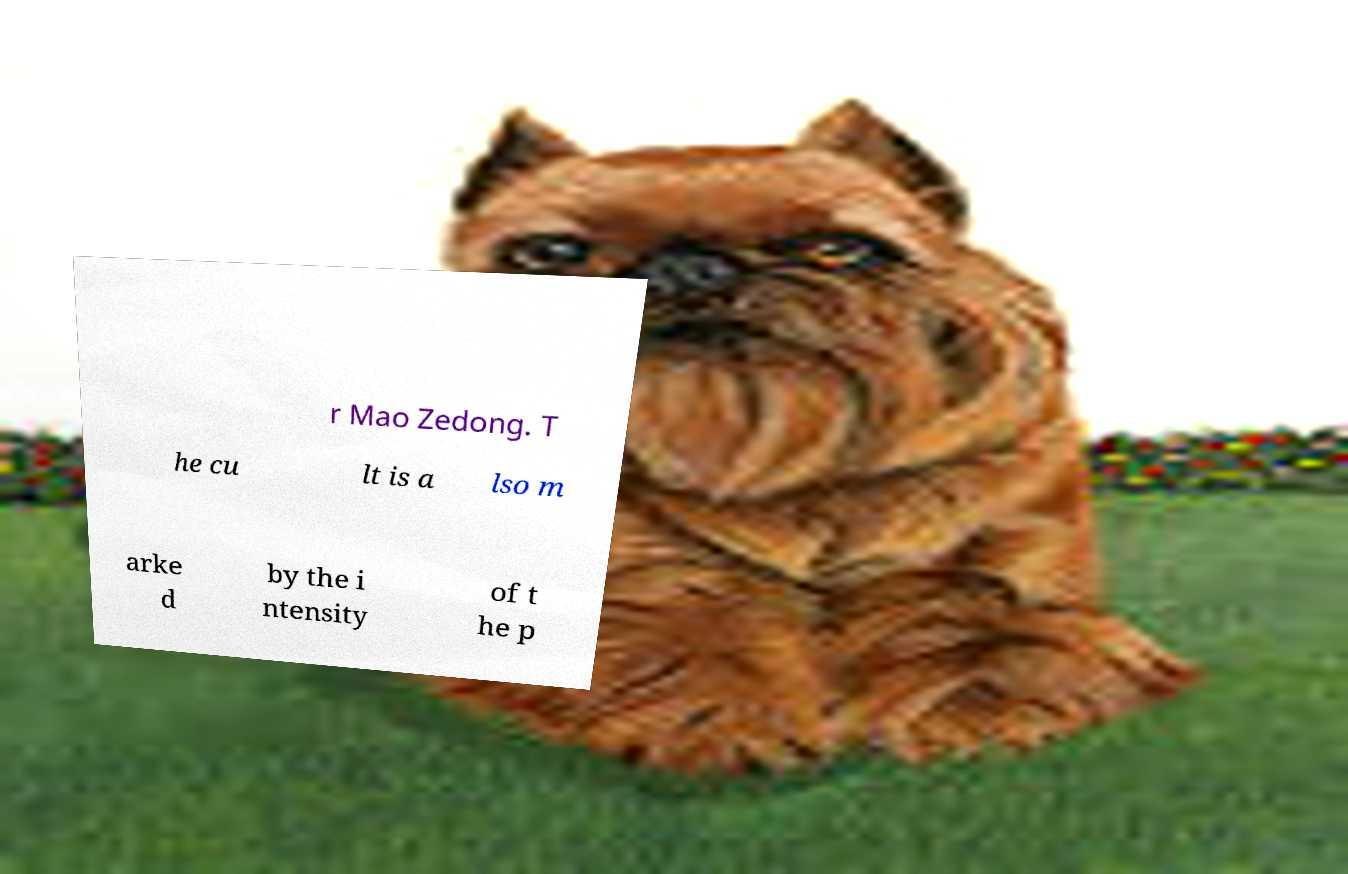Please read and relay the text visible in this image. What does it say? r Mao Zedong. T he cu lt is a lso m arke d by the i ntensity of t he p 